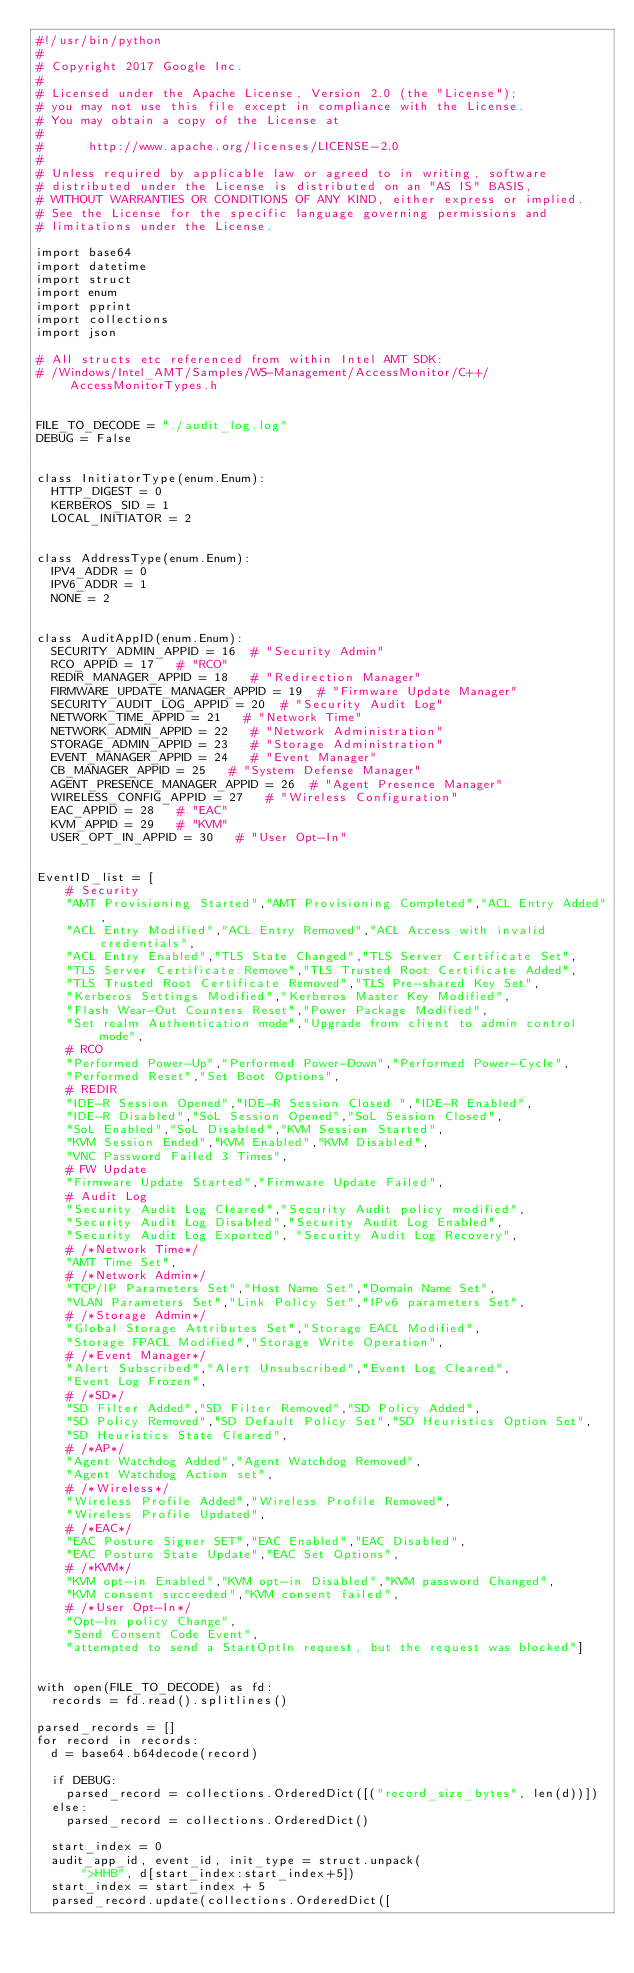Convert code to text. <code><loc_0><loc_0><loc_500><loc_500><_Python_>#!/usr/bin/python
#
# Copyright 2017 Google Inc.
#
# Licensed under the Apache License, Version 2.0 (the "License");
# you may not use this file except in compliance with the License.
# You may obtain a copy of the License at
#
#      http://www.apache.org/licenses/LICENSE-2.0
#
# Unless required by applicable law or agreed to in writing, software
# distributed under the License is distributed on an "AS IS" BASIS,
# WITHOUT WARRANTIES OR CONDITIONS OF ANY KIND, either express or implied.
# See the License for the specific language governing permissions and
# limitations under the License.

import base64
import datetime
import struct
import enum
import pprint
import collections
import json

# All structs etc referenced from within Intel AMT SDK:
# /Windows/Intel_AMT/Samples/WS-Management/AccessMonitor/C++/AccessMonitorTypes.h


FILE_TO_DECODE = "./audit_log.log"
DEBUG = False


class InitiatorType(enum.Enum):
  HTTP_DIGEST = 0
  KERBEROS_SID = 1
  LOCAL_INITIATOR = 2


class AddressType(enum.Enum):
  IPV4_ADDR = 0
  IPV6_ADDR = 1
  NONE = 2


class AuditAppID(enum.Enum):
  SECURITY_ADMIN_APPID = 16  # "Security Admin"
  RCO_APPID = 17   # "RCO"
  REDIR_MANAGER_APPID = 18   # "Redirection Manager"
  FIRMWARE_UPDATE_MANAGER_APPID = 19  # "Firmware Update Manager"
  SECURITY_AUDIT_LOG_APPID = 20  # "Security Audit Log"
  NETWORK_TIME_APPID = 21   # "Network Time"
  NETWORK_ADMIN_APPID = 22   # "Network Administration"
  STORAGE_ADMIN_APPID = 23   # "Storage Administration"
  EVENT_MANAGER_APPID = 24   # "Event Manager"
  CB_MANAGER_APPID = 25   # "System Defense Manager"
  AGENT_PRESENCE_MANAGER_APPID = 26  # "Agent Presence Manager"
  WIRELESS_CONFIG_APPID = 27   # "Wireless Configuration"
  EAC_APPID = 28   # "EAC"
  KVM_APPID = 29   # "KVM"
  USER_OPT_IN_APPID = 30   # "User Opt-In"


EventID_list = [
    # Security
    "AMT Provisioning Started","AMT Provisioning Completed","ACL Entry Added",
    "ACL Entry Modified","ACL Entry Removed","ACL Access with invalid credentials",
    "ACL Entry Enabled","TLS State Changed","TLS Server Certificate Set",
    "TLS Server Certificate Remove","TLS Trusted Root Certificate Added",
    "TLS Trusted Root Certificate Removed","TLS Pre-shared Key Set",
    "Kerberos Settings Modified","Kerberos Master Key Modified",
    "Flash Wear-Out Counters Reset","Power Package Modified",
    "Set realm Authentication mode","Upgrade from client to admin control mode",
    # RCO
    "Performed Power-Up","Performed Power-Down","Performed Power-Cycle",
    "Performed Reset","Set Boot Options",
    # REDIR
    "IDE-R Session Opened","IDE-R Session Closed ","IDE-R Enabled",
    "IDE-R Disabled","SoL Session Opened","SoL Session Closed",
    "SoL Enabled","SoL Disabled","KVM Session Started",
    "KVM Session Ended","KVM Enabled","KVM Disabled",
    "VNC Password Failed 3 Times",
    # FW Update
    "Firmware Update Started","Firmware Update Failed",
    # Audit Log
    "Security Audit Log Cleared","Security Audit policy modified",
    "Security Audit Log Disabled","Security Audit Log Enabled",
    "Security Audit Log Exported", "Security Audit Log Recovery",
    # /*Network Time*/
    "AMT Time Set",
    # /*Network Admin*/
    "TCP/IP Parameters Set","Host Name Set","Domain Name Set",
    "VLAN Parameters Set","Link Policy Set","IPv6 parameters Set",
    # /*Storage Admin*/
    "Global Storage Attributes Set","Storage EACL Modified",
    "Storage FPACL Modified","Storage Write Operation",
    # /*Event Manager*/
    "Alert Subscribed","Alert Unsubscribed","Event Log Cleared",
    "Event Log Frozen",
    # /*SD*/
    "SD Filter Added","SD Filter Removed","SD Policy Added",
    "SD Policy Removed","SD Default Policy Set","SD Heuristics Option Set",
    "SD Heuristics State Cleared",
    # /*AP*/
    "Agent Watchdog Added","Agent Watchdog Removed",
    "Agent Watchdog Action set",
    # /*Wireless*/
    "Wireless Profile Added","Wireless Profile Removed",
    "Wireless Profile Updated",
    # /*EAC*/
    "EAC Posture Signer SET","EAC Enabled","EAC Disabled",
    "EAC Posture State Update","EAC Set Options",
    # /*KVM*/
    "KVM opt-in Enabled","KVM opt-in Disabled","KVM password Changed",
    "KVM consent succeeded","KVM consent failed",
    # /*User Opt-In*/
    "Opt-In policy Change",
    "Send Consent Code Event",
    "attempted to send a StartOptIn request, but the request was blocked"]


with open(FILE_TO_DECODE) as fd:
  records = fd.read().splitlines()

parsed_records = []
for record in records:
  d = base64.b64decode(record)

  if DEBUG:
    parsed_record = collections.OrderedDict([("record_size_bytes", len(d))])
  else:
    parsed_record = collections.OrderedDict()

  start_index = 0
  audit_app_id, event_id, init_type = struct.unpack(
      ">HHB", d[start_index:start_index+5])
  start_index = start_index + 5
  parsed_record.update(collections.OrderedDict([</code> 